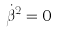Convert formula to latex. <formula><loc_0><loc_0><loc_500><loc_500>\dot { \beta } ^ { 2 } = 0</formula> 